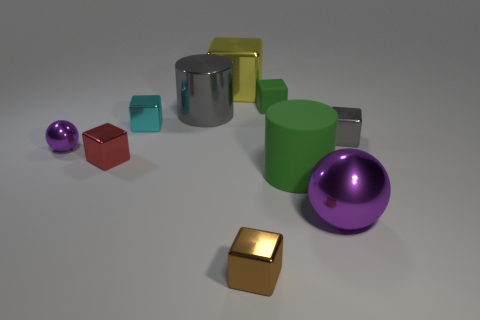Are there the same number of cyan metal objects in front of the yellow shiny block and tiny red shiny cubes behind the small gray block?
Give a very brief answer. No. What number of blue things are balls or small shiny cubes?
Provide a succinct answer. 0. There is a tiny ball; is it the same color as the metal ball that is in front of the tiny purple object?
Give a very brief answer. Yes. How many other things are the same color as the large metallic cylinder?
Your answer should be compact. 1. Are there fewer blocks than objects?
Your answer should be compact. Yes. What number of purple spheres are in front of the ball left of the purple sphere right of the yellow thing?
Provide a short and direct response. 1. There is a gray metallic object that is behind the small gray metal block; what size is it?
Make the answer very short. Large. Do the metal thing right of the big ball and the tiny red object have the same shape?
Give a very brief answer. Yes. There is a green object that is the same shape as the big gray object; what material is it?
Offer a terse response. Rubber. Are there any large metal blocks?
Your answer should be compact. Yes. 